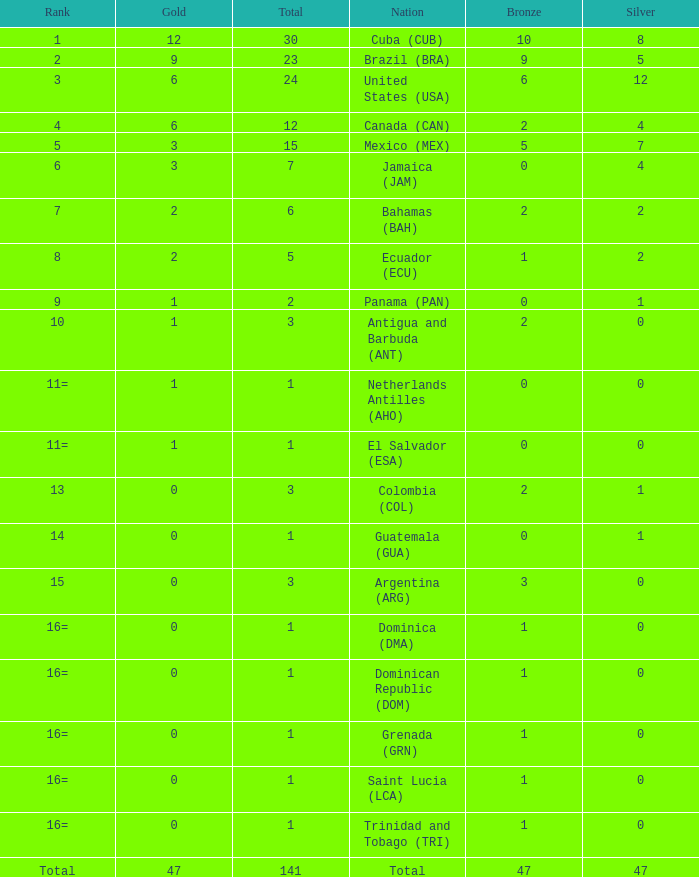What is the average silver with more than 0 gold, a Rank of 1, and a Total smaller than 30? None. 